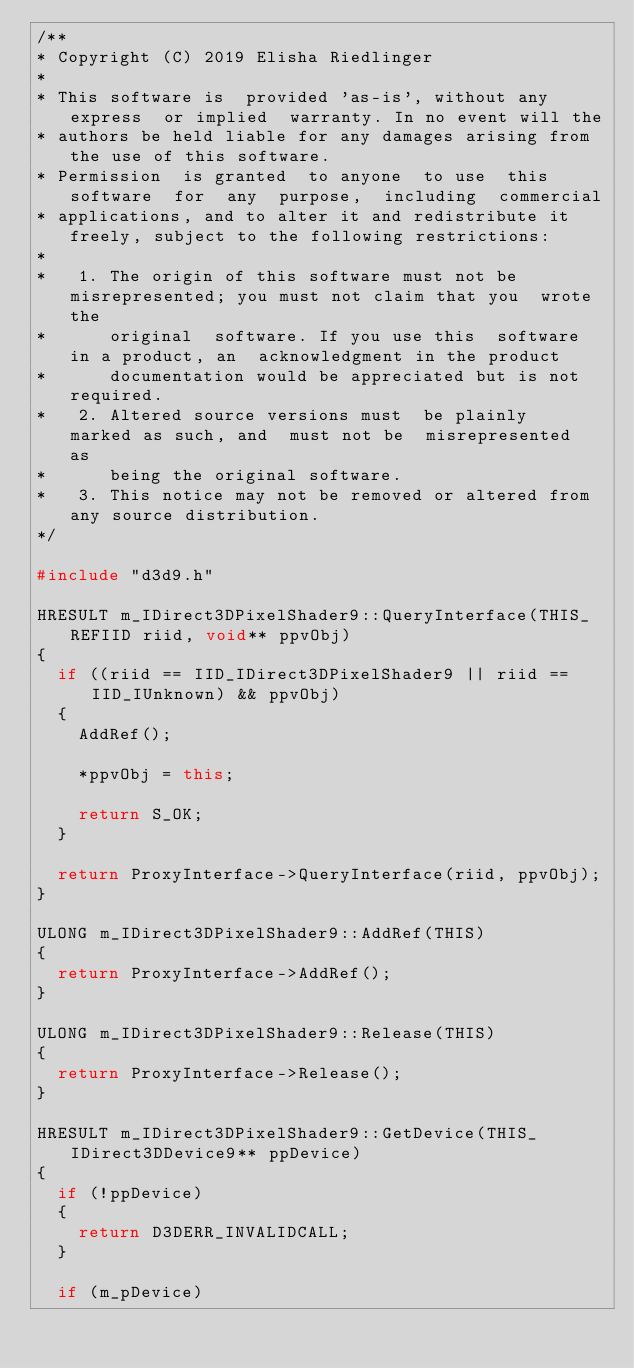<code> <loc_0><loc_0><loc_500><loc_500><_C++_>/**
* Copyright (C) 2019 Elisha Riedlinger
*
* This software is  provided 'as-is', without any express  or implied  warranty. In no event will the
* authors be held liable for any damages arising from the use of this software.
* Permission  is granted  to anyone  to use  this software  for  any  purpose,  including  commercial
* applications, and to alter it and redistribute it freely, subject to the following restrictions:
*
*   1. The origin of this software must not be misrepresented; you must not claim that you  wrote the
*      original  software. If you use this  software  in a product, an  acknowledgment in the product
*      documentation would be appreciated but is not required.
*   2. Altered source versions must  be plainly  marked as such, and  must not be  misrepresented  as
*      being the original software.
*   3. This notice may not be removed or altered from any source distribution.
*/

#include "d3d9.h"

HRESULT m_IDirect3DPixelShader9::QueryInterface(THIS_ REFIID riid, void** ppvObj)
{
	if ((riid == IID_IDirect3DPixelShader9 || riid == IID_IUnknown) && ppvObj)
	{
		AddRef();

		*ppvObj = this;

		return S_OK;
	}

	return ProxyInterface->QueryInterface(riid, ppvObj);
}

ULONG m_IDirect3DPixelShader9::AddRef(THIS)
{
	return ProxyInterface->AddRef();
}

ULONG m_IDirect3DPixelShader9::Release(THIS)
{
	return ProxyInterface->Release();
}

HRESULT m_IDirect3DPixelShader9::GetDevice(THIS_ IDirect3DDevice9** ppDevice)
{
	if (!ppDevice)
	{
		return D3DERR_INVALIDCALL;
	}

	if (m_pDevice)</code> 